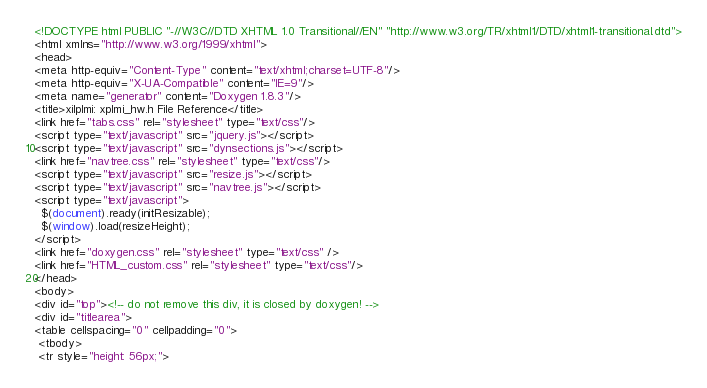<code> <loc_0><loc_0><loc_500><loc_500><_HTML_><!DOCTYPE html PUBLIC "-//W3C//DTD XHTML 1.0 Transitional//EN" "http://www.w3.org/TR/xhtml1/DTD/xhtml1-transitional.dtd">
<html xmlns="http://www.w3.org/1999/xhtml">
<head>
<meta http-equiv="Content-Type" content="text/xhtml;charset=UTF-8"/>
<meta http-equiv="X-UA-Compatible" content="IE=9"/>
<meta name="generator" content="Doxygen 1.8.3"/>
<title>xilplmi: xplmi_hw.h File Reference</title>
<link href="tabs.css" rel="stylesheet" type="text/css"/>
<script type="text/javascript" src="jquery.js"></script>
<script type="text/javascript" src="dynsections.js"></script>
<link href="navtree.css" rel="stylesheet" type="text/css"/>
<script type="text/javascript" src="resize.js"></script>
<script type="text/javascript" src="navtree.js"></script>
<script type="text/javascript">
  $(document).ready(initResizable);
  $(window).load(resizeHeight);
</script>
<link href="doxygen.css" rel="stylesheet" type="text/css" />
<link href="HTML_custom.css" rel="stylesheet" type="text/css"/>
</head>
<body>
<div id="top"><!-- do not remove this div, it is closed by doxygen! -->
<div id="titlearea">
<table cellspacing="0" cellpadding="0">
 <tbody>
 <tr style="height: 56px;"></code> 